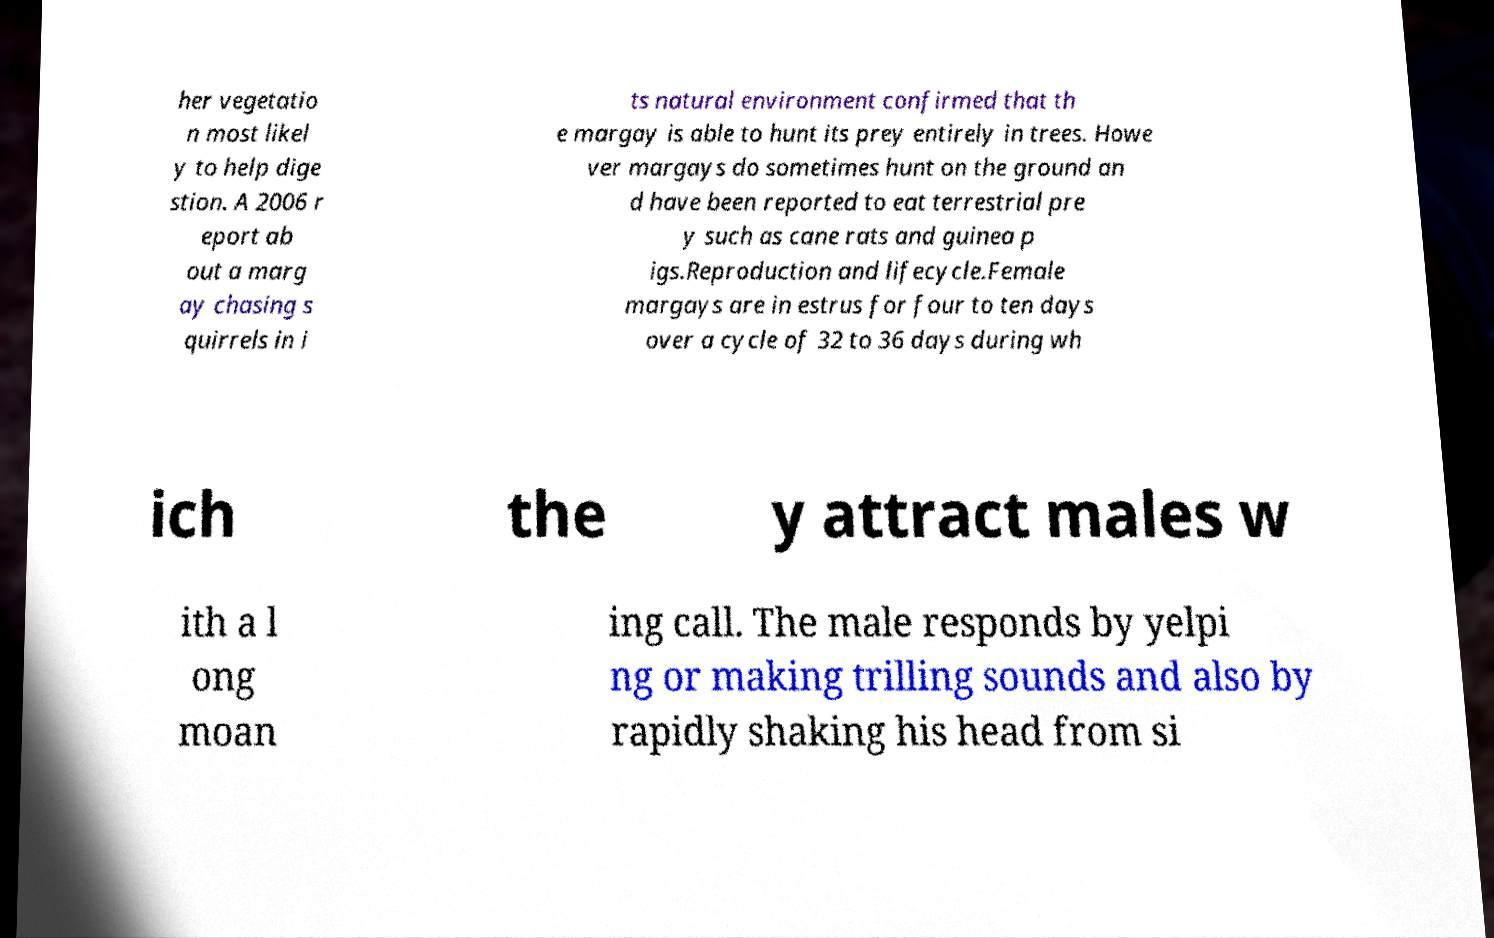Could you extract and type out the text from this image? her vegetatio n most likel y to help dige stion. A 2006 r eport ab out a marg ay chasing s quirrels in i ts natural environment confirmed that th e margay is able to hunt its prey entirely in trees. Howe ver margays do sometimes hunt on the ground an d have been reported to eat terrestrial pre y such as cane rats and guinea p igs.Reproduction and lifecycle.Female margays are in estrus for four to ten days over a cycle of 32 to 36 days during wh ich the y attract males w ith a l ong moan ing call. The male responds by yelpi ng or making trilling sounds and also by rapidly shaking his head from si 